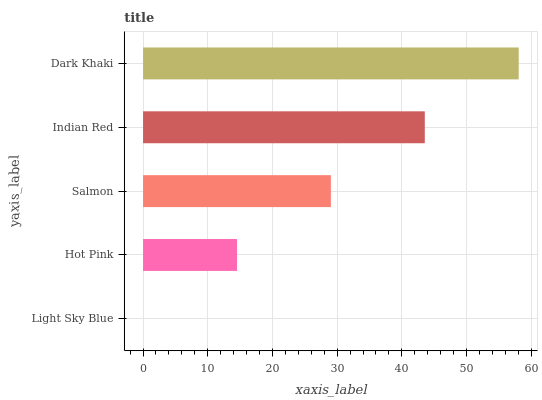Is Light Sky Blue the minimum?
Answer yes or no. Yes. Is Dark Khaki the maximum?
Answer yes or no. Yes. Is Hot Pink the minimum?
Answer yes or no. No. Is Hot Pink the maximum?
Answer yes or no. No. Is Hot Pink greater than Light Sky Blue?
Answer yes or no. Yes. Is Light Sky Blue less than Hot Pink?
Answer yes or no. Yes. Is Light Sky Blue greater than Hot Pink?
Answer yes or no. No. Is Hot Pink less than Light Sky Blue?
Answer yes or no. No. Is Salmon the high median?
Answer yes or no. Yes. Is Salmon the low median?
Answer yes or no. Yes. Is Hot Pink the high median?
Answer yes or no. No. Is Light Sky Blue the low median?
Answer yes or no. No. 